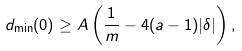<formula> <loc_0><loc_0><loc_500><loc_500>d _ { \min } ( 0 ) \geq A \left ( \frac { 1 } { m } - 4 ( a - 1 ) | \delta | \right ) ,</formula> 